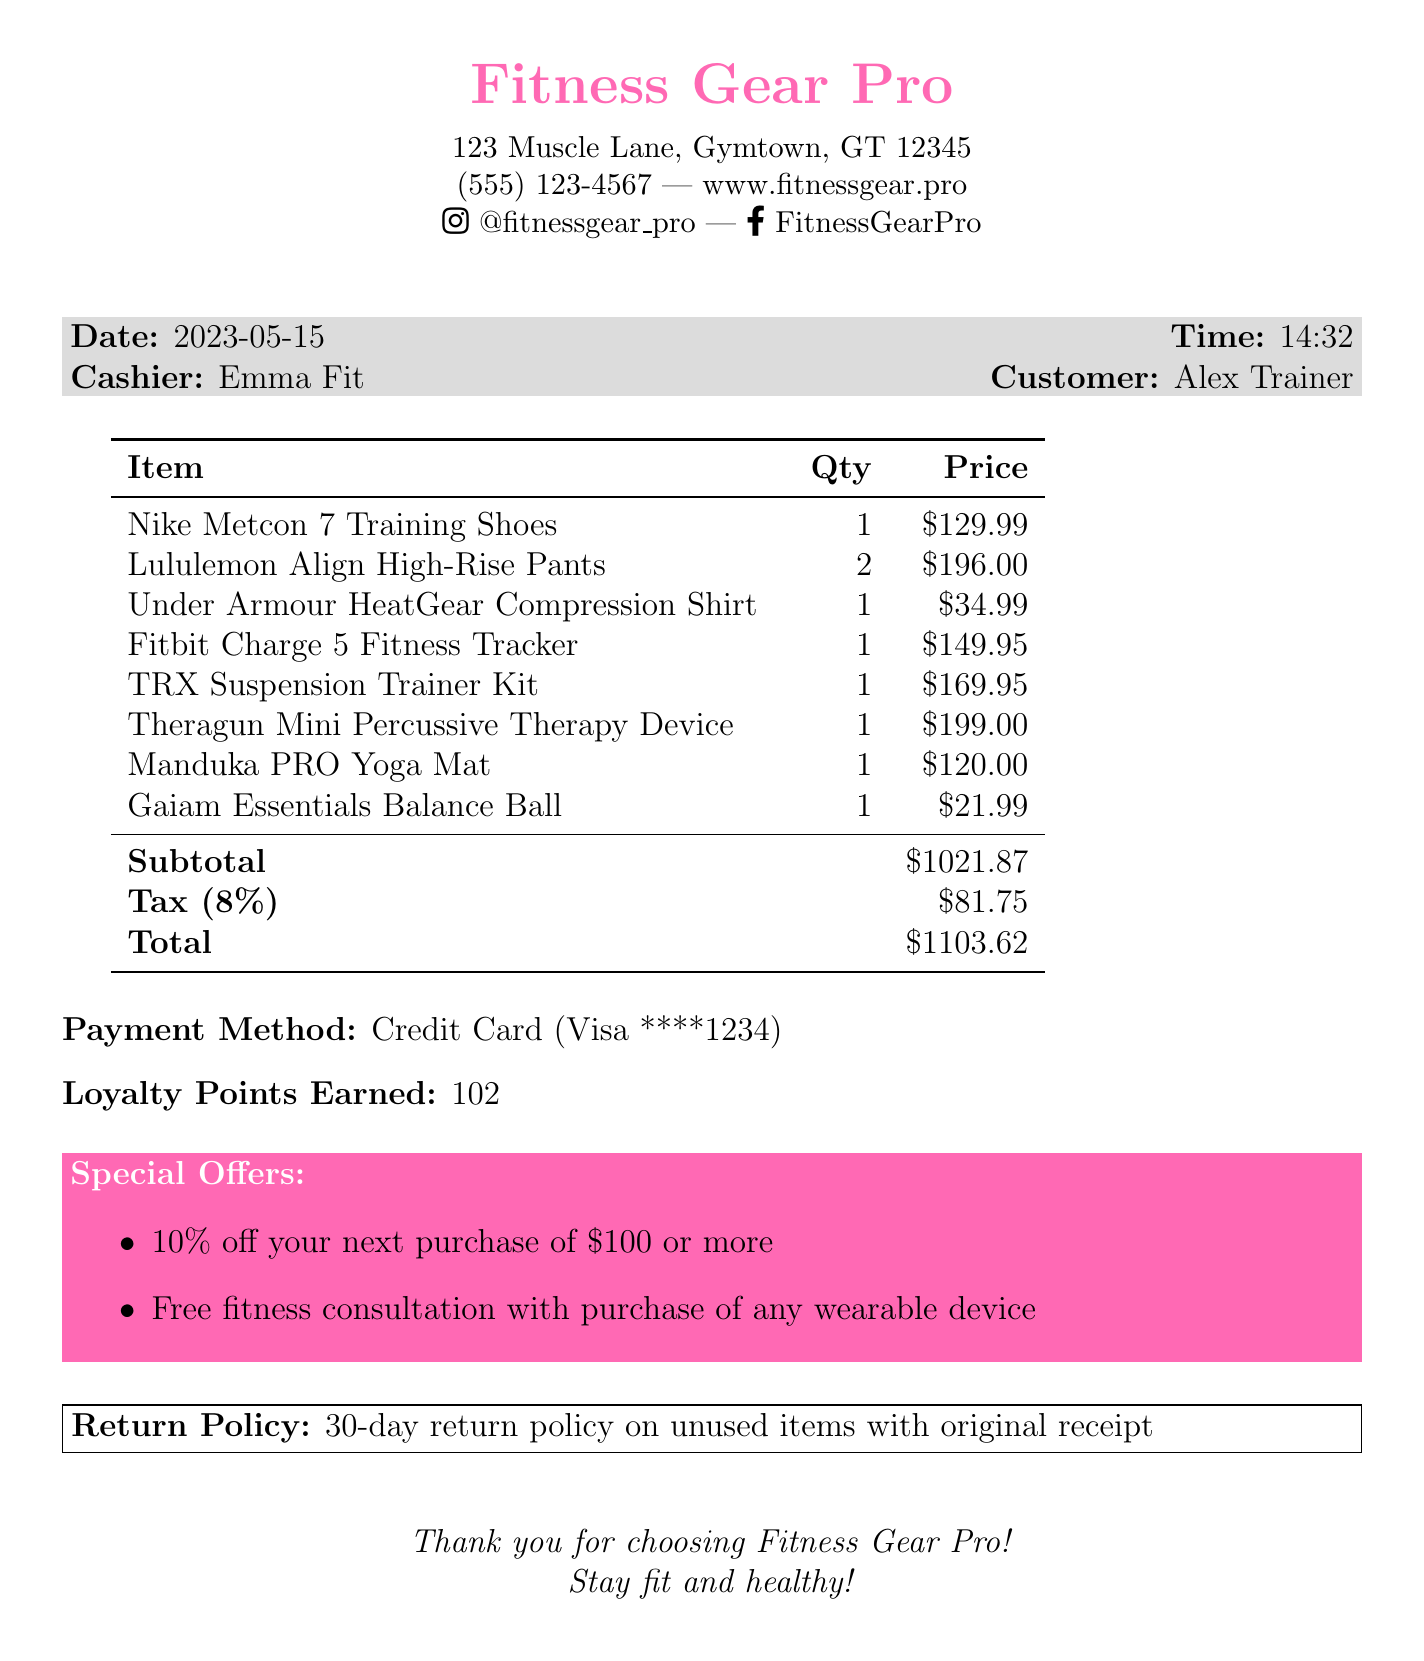What is the store name? The store name is shown at the top of the receipt.
Answer: Fitness Gear Pro What is the date of purchase? The date is listed in the document under the purchase details.
Answer: 2023-05-15 Who was the cashier? The cashier's name is provided in the receipt details.
Answer: Emma Fit What is the total amount spent? The total is calculated by adding the subtotal and tax amount.
Answer: 1103.62 How many Lululemon Align High-Rise Pants were purchased? The quantity is specified next to the item on the receipt.
Answer: 2 What is the tax amount? The tax amount is detailed at the bottom of the receipt following the subtotal.
Answer: 81.75 What is the return policy? The return policy is stated in a box near the bottom of the receipt.
Answer: 30-day return policy on unused items with original receipt How many loyalty points were earned from this purchase? The loyalty points earned are mentioned in the payment details section.
Answer: 102 What is the discount offer on the next purchase? The special offers section includes a discount for future purchases.
Answer: 10% off your next purchase of $100 or more 